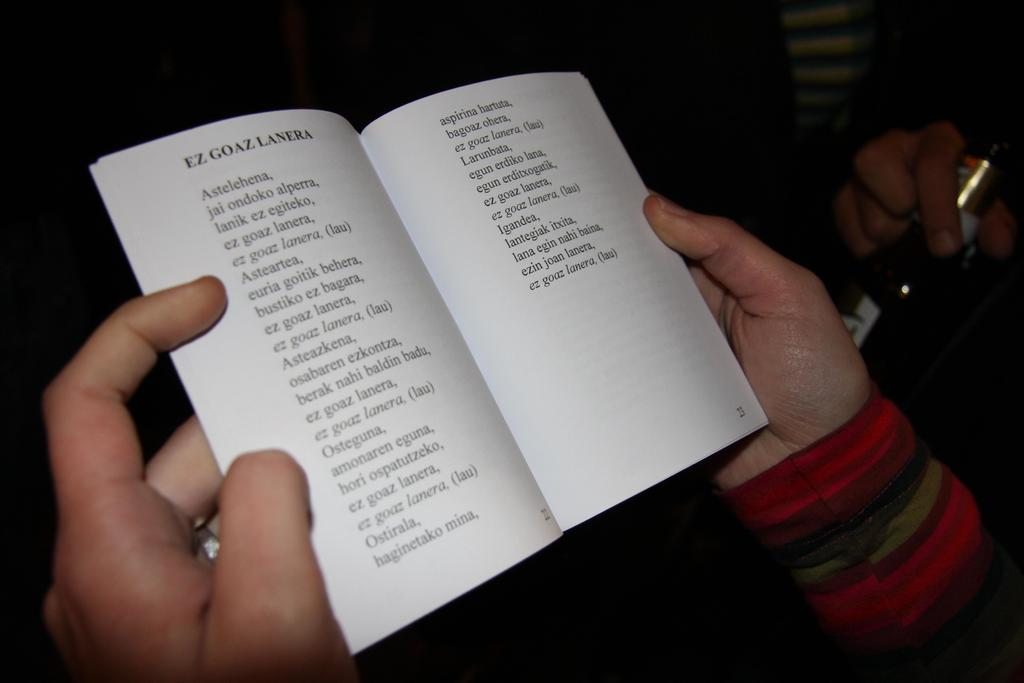<image>
Write a terse but informative summary of the picture. A person holding a thin book to a page with list of foreign words. 